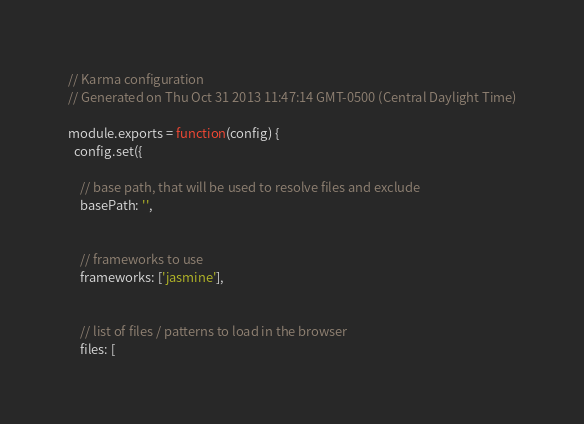Convert code to text. <code><loc_0><loc_0><loc_500><loc_500><_JavaScript_>// Karma configuration
// Generated on Thu Oct 31 2013 11:47:14 GMT-0500 (Central Daylight Time)

module.exports = function(config) {
  config.set({

    // base path, that will be used to resolve files and exclude
    basePath: '',


    // frameworks to use
    frameworks: ['jasmine'],


    // list of files / patterns to load in the browser
    files: [</code> 